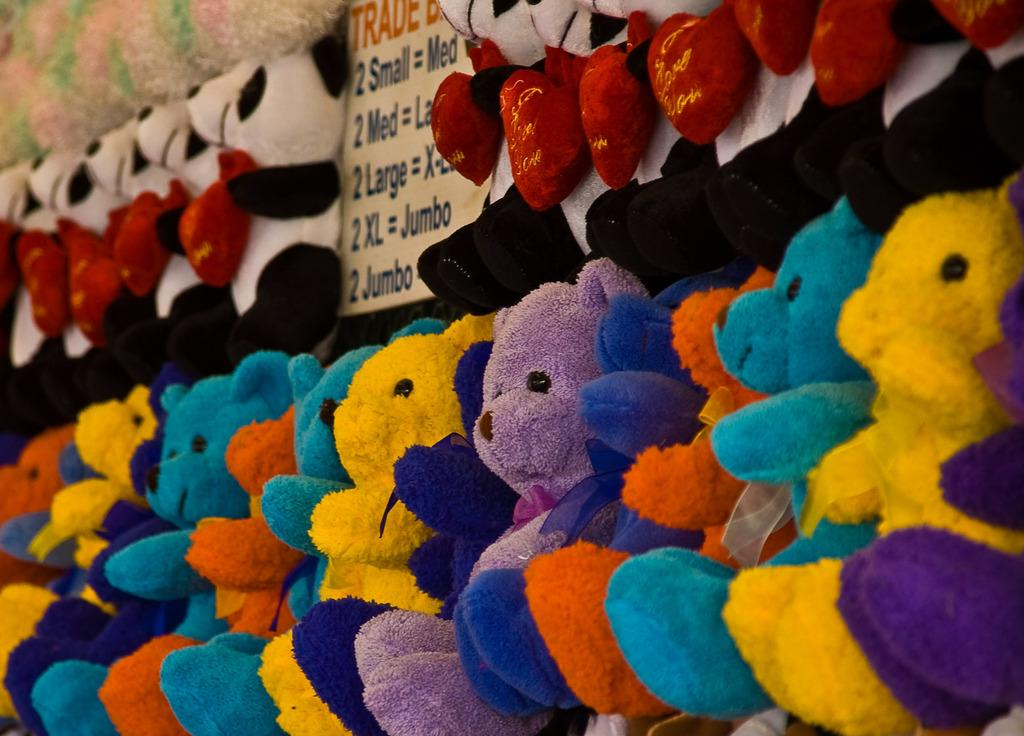What type of dolls are present in the image? There are teddy bear dolls in the image. Can you describe the appearance of the teddy bear dolls? The teddy bear dolls have different colors. What else can be seen in the image besides the teddy bear dolls? There is a banner in the image. What type of vest is the stranger wearing in the image? There is no stranger present in the image, so it is not possible to determine what type of vest they might be wearing. 